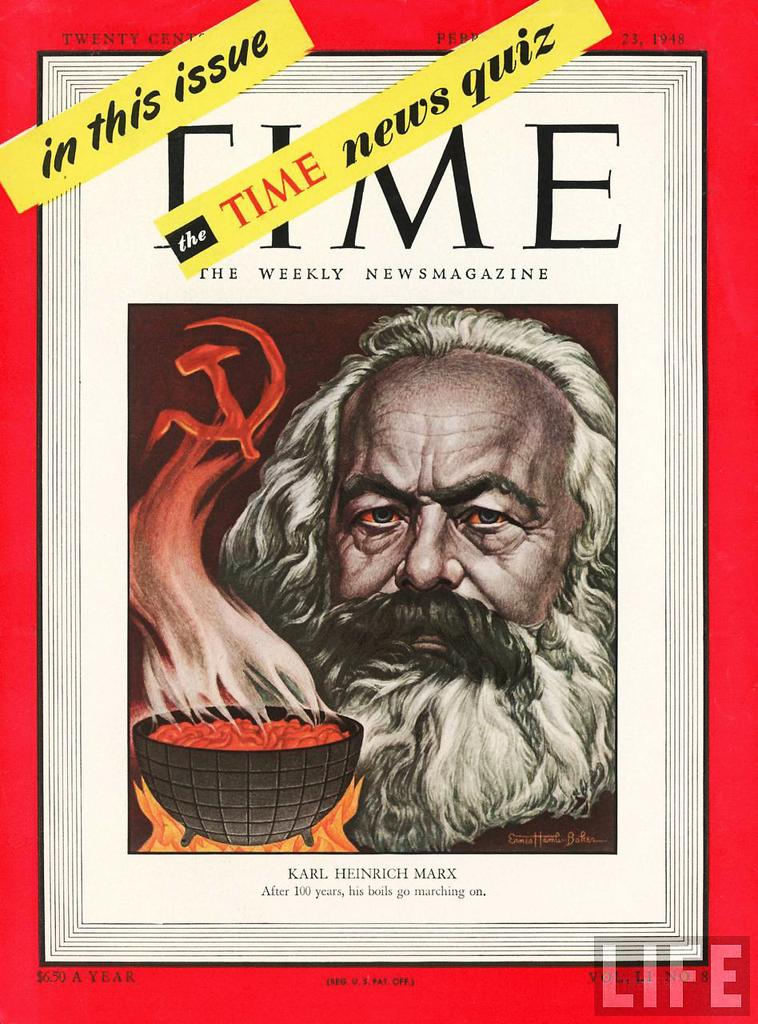<image>
Describe the image concisely. A Time Magazine cover features a portrait of Karl Heinrich Marx. 